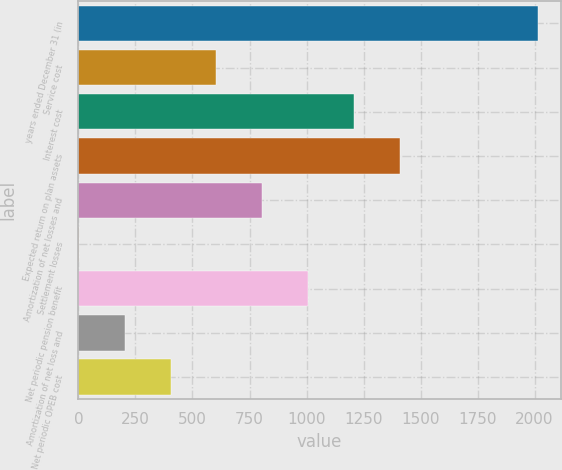Convert chart. <chart><loc_0><loc_0><loc_500><loc_500><bar_chart><fcel>years ended December 31 (in<fcel>Service cost<fcel>Interest cost<fcel>Expected return on plan assets<fcel>Amortization of net losses and<fcel>Settlement losses<fcel>Net periodic pension benefit<fcel>Amortization of net loss and<fcel>Net periodic OPEB cost<nl><fcel>2014<fcel>604.9<fcel>1208.8<fcel>1410.1<fcel>806.2<fcel>1<fcel>1007.5<fcel>202.3<fcel>403.6<nl></chart> 